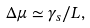<formula> <loc_0><loc_0><loc_500><loc_500>\Delta \mu \simeq \gamma _ { s } / L ,</formula> 